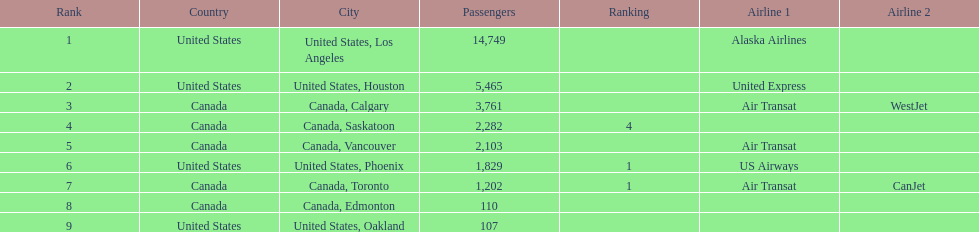Was los angeles or houston the busiest international route at manzanillo international airport in 2013? Los Angeles. 